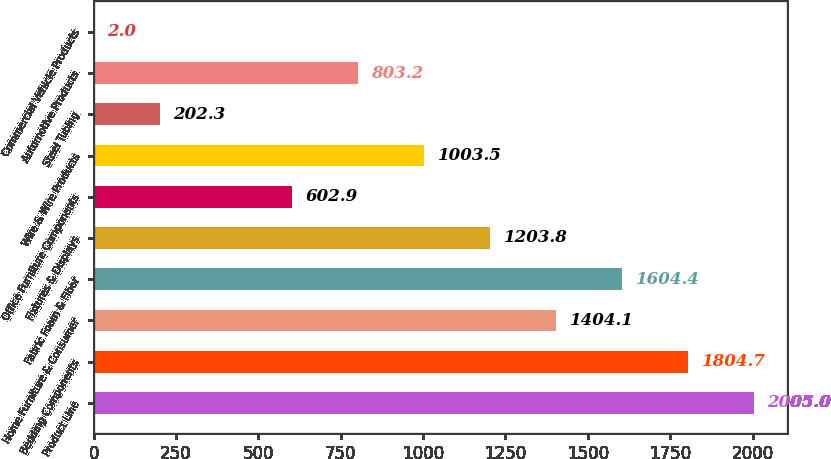Convert chart. <chart><loc_0><loc_0><loc_500><loc_500><bar_chart><fcel>Product Line<fcel>Bedding Components<fcel>Home Furniture & Consumer<fcel>Fabric Foam & Fiber<fcel>Fixtures & Displays<fcel>Office Furniture Components<fcel>Wire & Wire Products<fcel>Steel Tubing<fcel>Automotive Products<fcel>Commercial Vehicle Products<nl><fcel>2005<fcel>1804.7<fcel>1404.1<fcel>1604.4<fcel>1203.8<fcel>602.9<fcel>1003.5<fcel>202.3<fcel>803.2<fcel>2<nl></chart> 